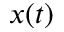Convert formula to latex. <formula><loc_0><loc_0><loc_500><loc_500>x ( t )</formula> 